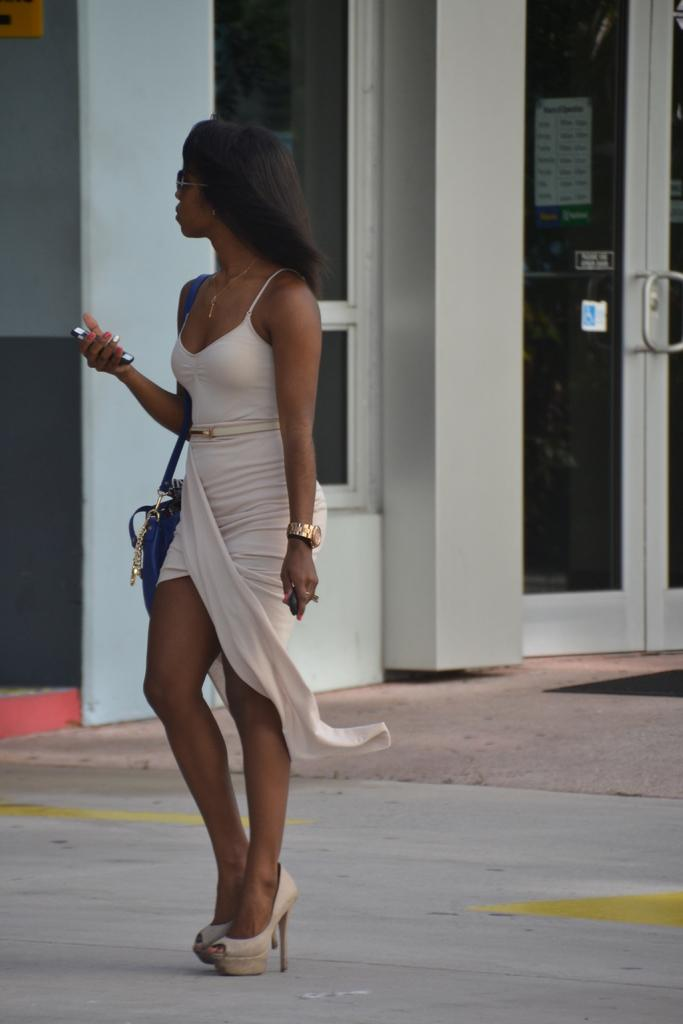What is the main subject of the image? There is a woman standing in the image. What is the woman standing on? The woman is standing on the floor. What can be seen in the background of the image? There is a door and a wall in the background of the image. What type of hammer is the woman holding in the image? There is no hammer present in the image; the woman is not holding anything. 